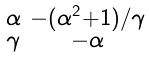<formula> <loc_0><loc_0><loc_500><loc_500>\begin{smallmatrix} \alpha & - ( \alpha ^ { 2 } + 1 ) / \gamma \\ \gamma & - \alpha \end{smallmatrix}</formula> 